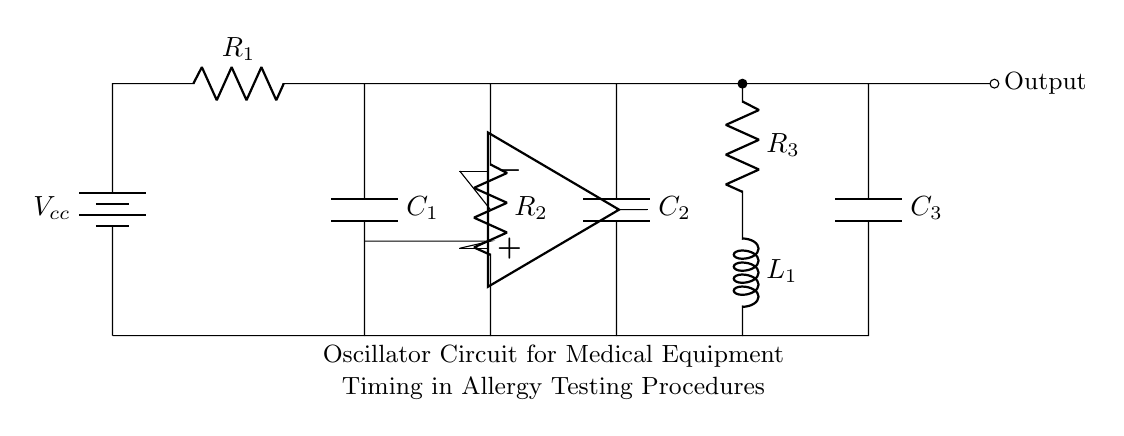What components are present in the circuit? The circuit includes a battery, resistors, capacitors, an inductor, and an operational amplifier, which are all necessary for the oscillation process.
Answer: battery, resistors, capacitors, inductor, operational amplifier What is the purpose of the operational amplifier in this circuit? The operational amplifier amplifies the voltage signal to help maintain the oscillation, providing the necessary feedback for consistent timing in the oscillator circuit.
Answer: feedback How many resistors are used in this oscillator circuit? By counting the components shown in the diagram, there are three resistors connected in different locations of the circuit.
Answer: three What is the role of capacitors in the circuitry? The capacitors in the circuit store and release electrical energy, which is crucial for generating oscillations and defining the frequency of the output signal.
Answer: generate oscillations What is the output type of this oscillator circuit? The output in this circuit, indicated at the end of the diagram, represents an oscillating voltage signal which is critical for timing in allergy testing equipment.
Answer: oscillating voltage How does the inductor influence the oscillation frequency? The inductor, together with capacitors and resistors, forms a resonant circuit, determining the frequency based on the formula involving their values, which defines the timing accuracy needed in medical equipment.
Answer: timing accuracy What is the voltage source labeled as in the circuit? The voltage source is labeled as Vcc, which indicates the direct current supply voltage required to power the oscillator circuit.
Answer: Vcc 